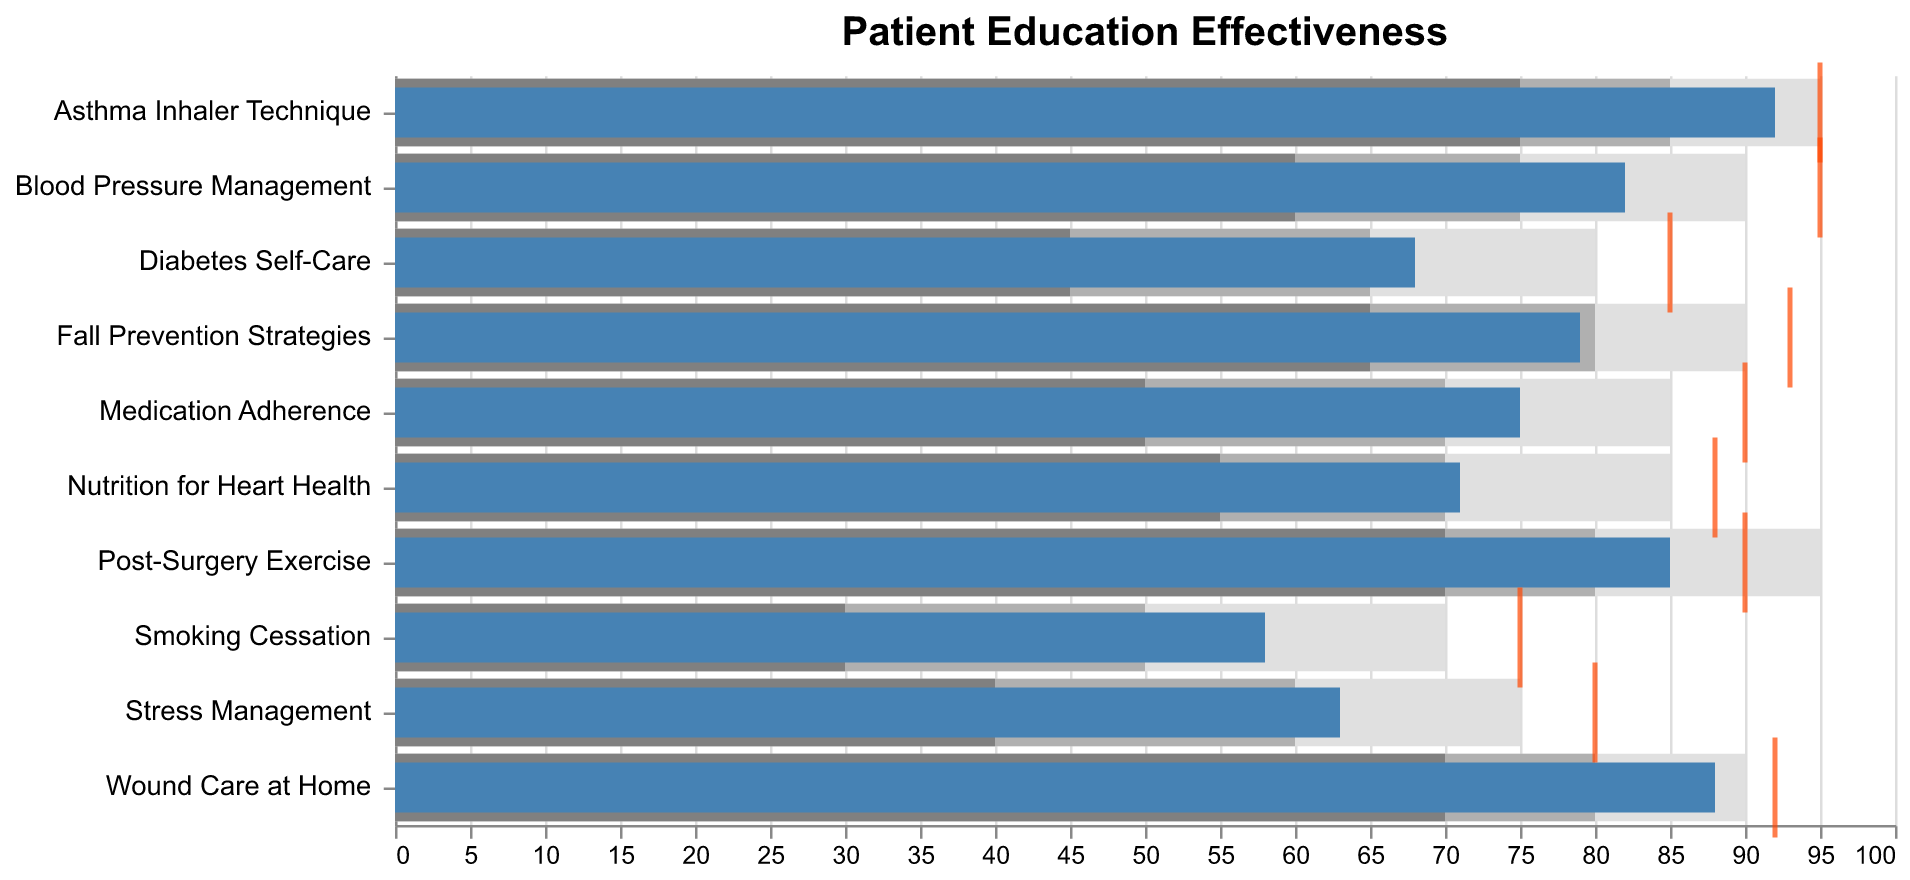What's the highest Target effectiveness score? The highest Target effectiveness score can be obtained by looking at the tick markers in the figure that indicate the Target value. The highest score is 95 for "Blood Pressure Management", "Asthma Inhaler Technique".
Answer: 95 Which category has the highest Actual effectiveness score? To identify the category with the highest Actual score, look at the bars representing the Actual values. The highest Actual score is 92 for "Asthma Inhaler Technique".
Answer: Asthma Inhaler Technique Is the Actual score for "Smoking Cessation" within the Range3 limits? We need to identify the Actual score for "Smoking Cessation" and compare it to the Range3 limits. The Actual score is 58, and the Range3 limit is 70. Since 58 is less than 70, it is not within Range3.
Answer: No How many categories have Actual scores greater than 80? Count the bars representing Actual scores that surpass the 80 mark. They are "Blood Pressure Management", "Wound Care at Home", "Post-Surgery Exercise", and "Asthma Inhaler Technique". Thus, there are 4 categories.
Answer: 4 In which categories is the Actual score closest to the Target score? To determine where Actual and Target scores are closest, calculate the absolute difference between them for each category. The smallest difference is 2 in "Wound Care at Home".
Answer: Wound Care at Home Which category has the largest gap between its Actual and Target score? To find the largest gap, calculate the difference between the Actual and Target scores in each category. The largest gap is 17 for "Medication Adherence" (90 - 75 = 15).
Answer: Medication Adherence Is the Actual score for "Wound Care at Home" above the Range2 limit? Identify the Actual score for "Wound Care at Home" and compare it to the Range2 limit. The Actual score is 88 and the Range2 limit is 80. Since 88 is higher than 80, it is above Range2.
Answer: Yes What's the average Actual score across all categories? Sum all Actual scores and divide by the number of categories. The sum of Actual scores is 75 + 82 + 68 + 88 + 71 + 79 + 85 + 92 + 63 + 58 = 761. There are 10 categories. Therefore, the average is 761 / 10 = 76.1.
Answer: 76.1 Is there any category where the Actual score meets the Target score exactly? Check if any Actual score is exactly equal to the Target score. There is no category where Actual equals Target.
Answer: No Does the category "Stress Management" meet its Range1 effectiveness level? Compare the Actual score of "Stress Management" (63) with its Range1 limit (40). Since 63 is greater than 40, it meets its Range1 effectiveness level.
Answer: Yes 